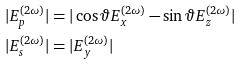<formula> <loc_0><loc_0><loc_500><loc_500>| E ^ { ( 2 \omega ) } _ { p } | & = | \cos \vartheta E ^ { ( 2 \omega ) } _ { x } - \sin \vartheta E ^ { ( 2 \omega ) } _ { z } | \\ | E ^ { ( 2 \omega ) } _ { s } | & = | E ^ { ( 2 \omega ) } _ { y } |</formula> 